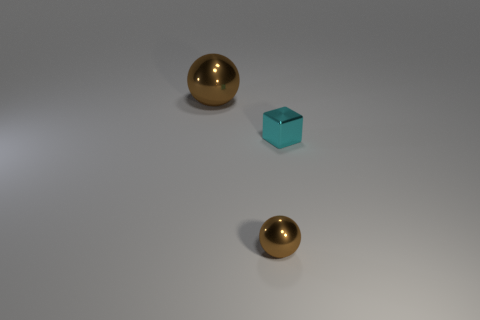Add 3 cyan metallic objects. How many objects exist? 6 Subtract all balls. How many objects are left? 1 Add 1 big blue shiny cylinders. How many big blue shiny cylinders exist? 1 Subtract 0 gray cylinders. How many objects are left? 3 Subtract all big cyan cylinders. Subtract all cyan metallic blocks. How many objects are left? 2 Add 2 brown metal objects. How many brown metal objects are left? 4 